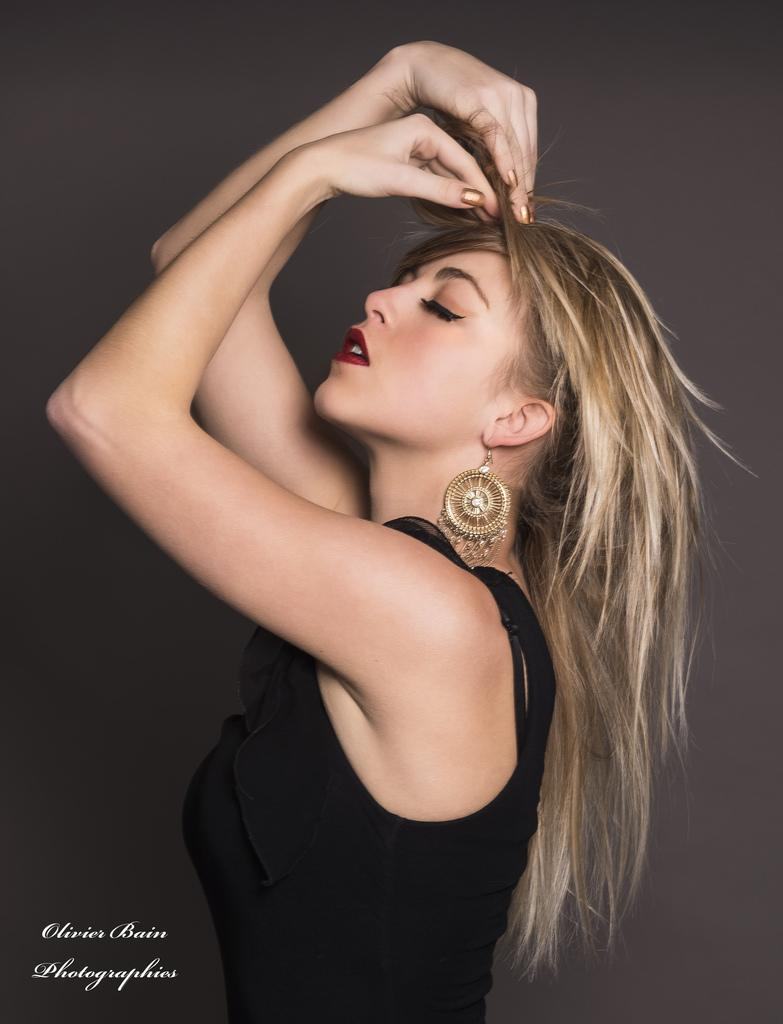What is the main subject of the image? There is a woman standing in the image. Can you describe the woman's attire? The woman is wearing a black dress and an earring. Is there any indication of the image's origin or ownership? Yes, there is a watermark on the image. What color is the background of the image? The background of the image appears to be grey in color. Can you tell me how many worms are crawling on the woman's dress in the image? There are no worms present in the image; the woman is wearing a black dress. What type of alarm is going off in the background of the image? There is no alarm present in the image; the background appears to be grey in color. 